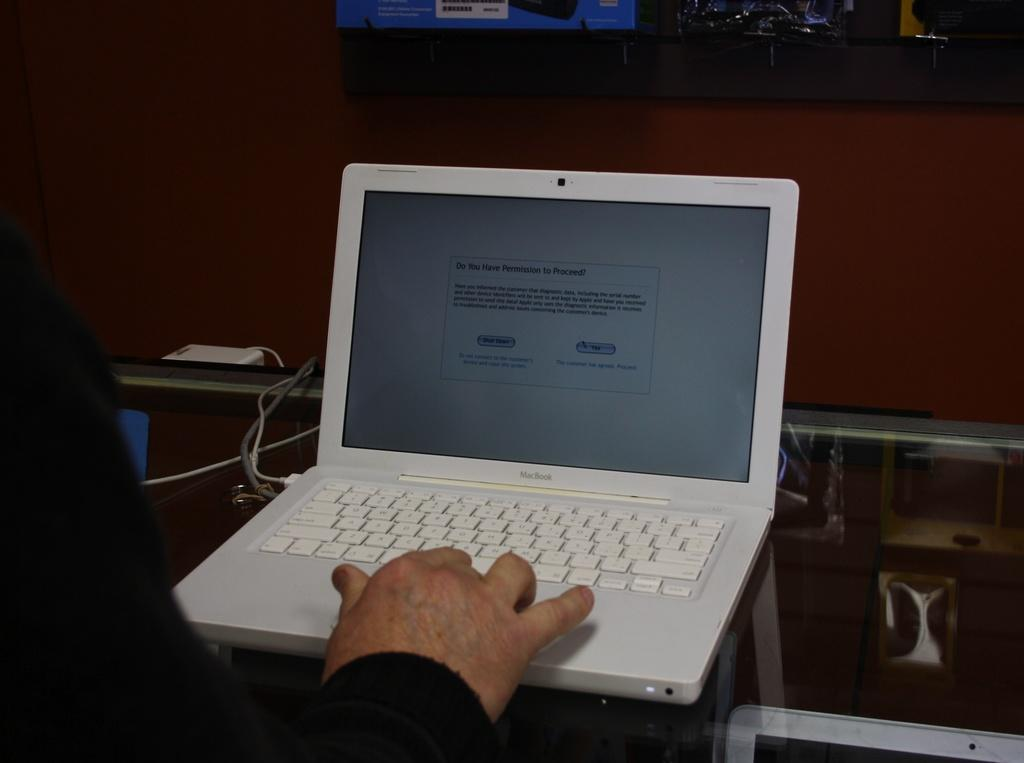<image>
Summarize the visual content of the image. a screen on a computer asking for permission 